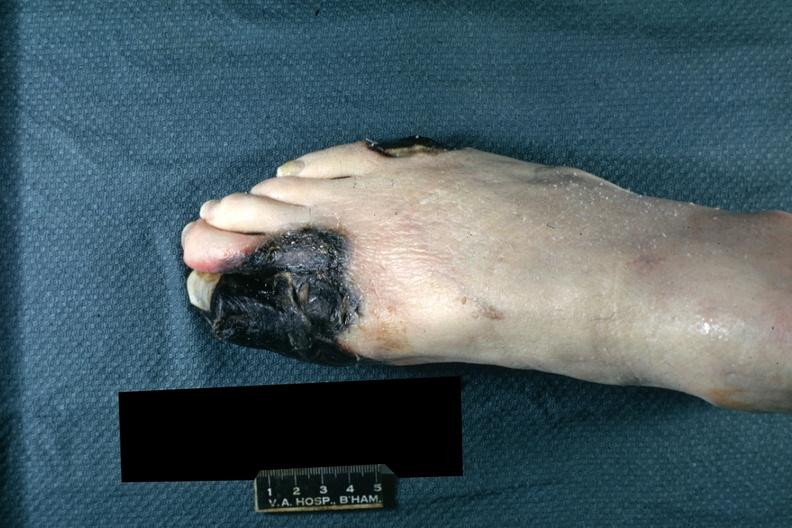what are present?
Answer the question using a single word or phrase. Extremities 